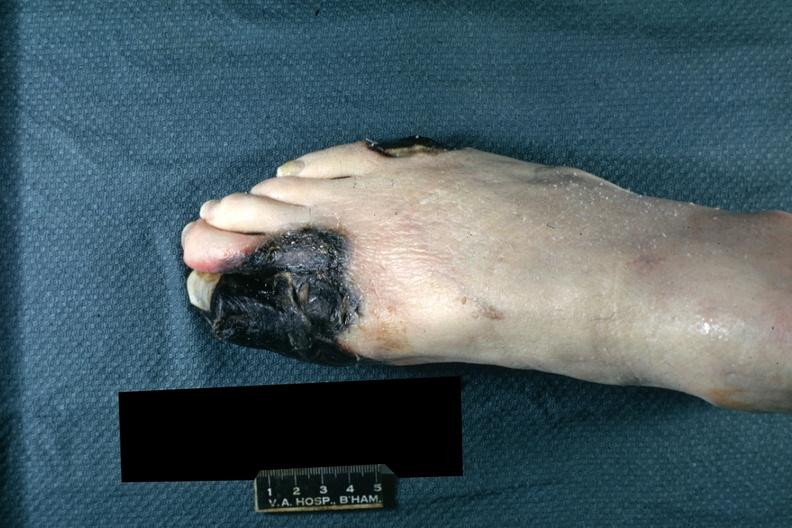what are present?
Answer the question using a single word or phrase. Extremities 